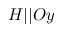<formula> <loc_0><loc_0><loc_500><loc_500>H | | O y</formula> 